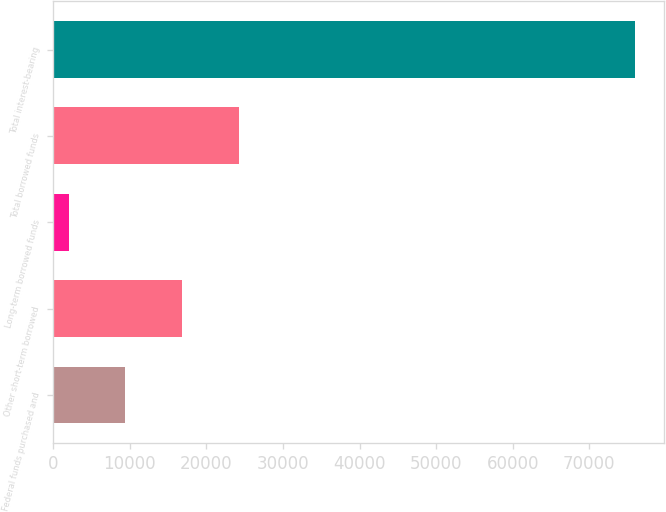Convert chart to OTSL. <chart><loc_0><loc_0><loc_500><loc_500><bar_chart><fcel>Federal funds purchased and<fcel>Other short-term borrowed<fcel>Long-term borrowed funds<fcel>Total borrowed funds<fcel>Total interest-bearing<nl><fcel>9380.7<fcel>16785.4<fcel>1976<fcel>24190.1<fcel>76023<nl></chart> 